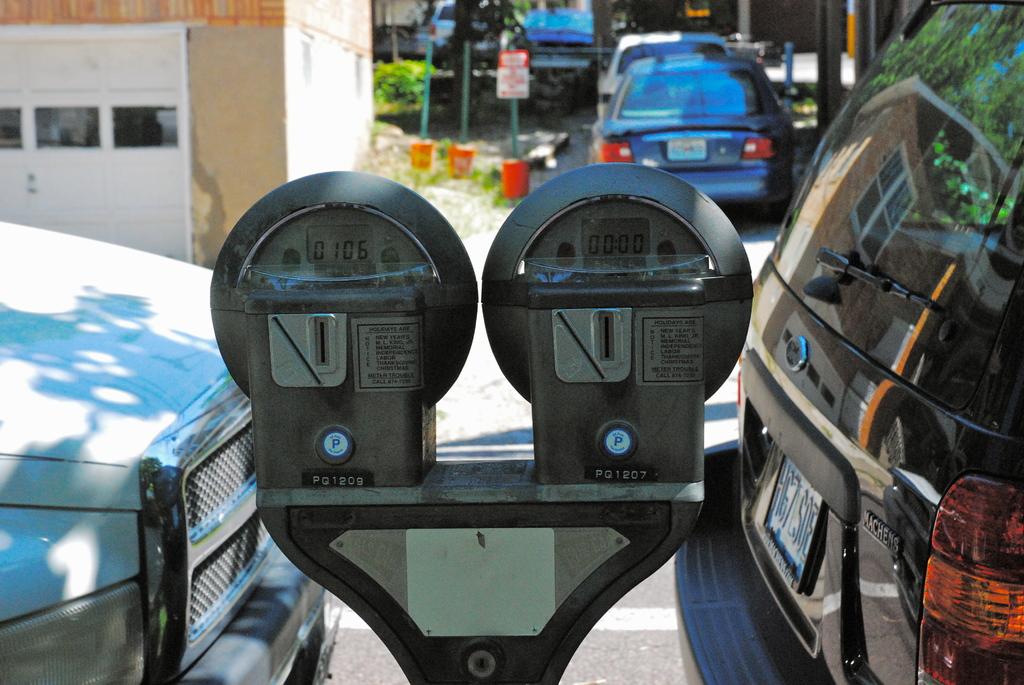What is the time left on the leftmost meter?
Your response must be concise. 0106. What is this called where you pay to park?
Make the answer very short. Answering does not require reading text in the image. 